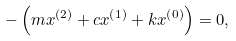<formula> <loc_0><loc_0><loc_500><loc_500>- \left ( m x ^ { \left ( 2 \right ) } + c x ^ { \left ( 1 \right ) } + k x ^ { \left ( 0 \right ) } \right ) = 0 ,</formula> 